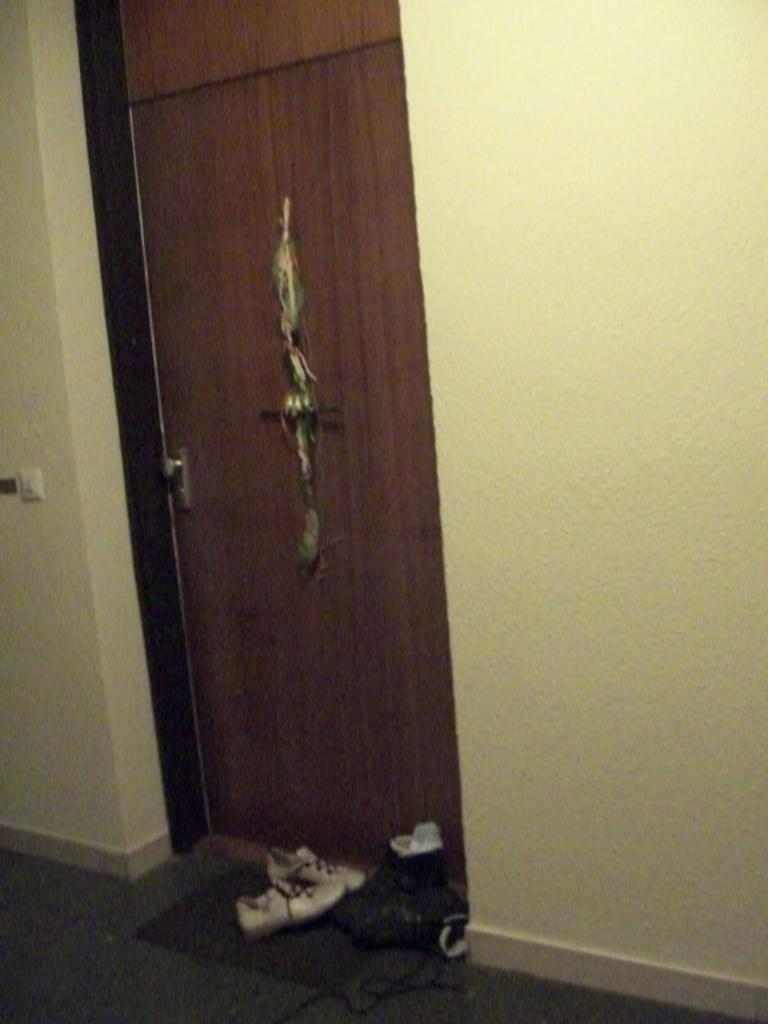What is located in the foreground of the image? There is a door and a wall in the foreground of the image. What can be seen on the floor in the image? There are pairs of shoes on the floor in the image. Where was the image taken? The image was taken in a room. What type of request can be seen written on the wall in the image? There is no request written on the wall in the image; it only shows a door, a wall, and pairs of shoes on the floor. Can you tell me how many pickles are related to the image? There is no mention of pickles in the image or the provided facts. 